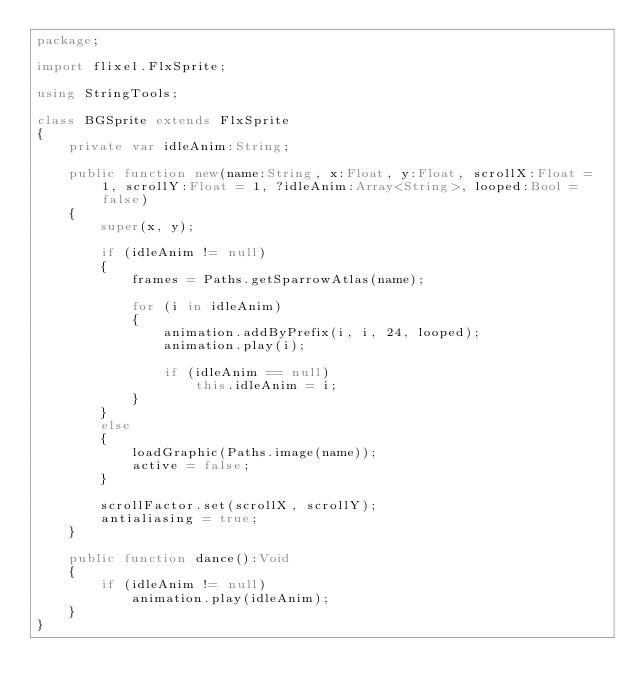Convert code to text. <code><loc_0><loc_0><loc_500><loc_500><_Haxe_>package;

import flixel.FlxSprite;

using StringTools;

class BGSprite extends FlxSprite
{
	private var idleAnim:String;

	public function new(name:String, x:Float, y:Float, scrollX:Float = 1, scrollY:Float = 1, ?idleAnim:Array<String>, looped:Bool = false)
	{
		super(x, y);

		if (idleAnim != null)
		{
			frames = Paths.getSparrowAtlas(name);

			for (i in idleAnim)
			{
				animation.addByPrefix(i, i, 24, looped);
				animation.play(i);

				if (idleAnim == null)
					this.idleAnim = i;
			}
		}
		else
		{
			loadGraphic(Paths.image(name));
			active = false;
		}

        scrollFactor.set(scrollX, scrollY);
		antialiasing = true;
	}

	public function dance():Void
	{
		if (idleAnim != null)
			animation.play(idleAnim);
	}
}
</code> 